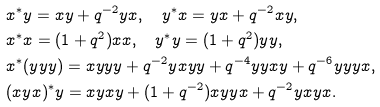<formula> <loc_0><loc_0><loc_500><loc_500>& x ^ { * } y = x y + q ^ { - 2 } y x , \quad y ^ { * } x = y x + q ^ { - 2 } x y , \\ & x ^ { * } x = ( 1 + q ^ { 2 } ) x x , \quad y ^ { * } y = ( 1 + q ^ { 2 } ) y y , \\ & x ^ { * } ( y y y ) = x y y y + q ^ { - 2 } y x y y + q ^ { - 4 } y y x y + q ^ { - 6 } y y y x , \\ & ( x y x ) ^ { * } y = x y x y + ( 1 + q ^ { - 2 } ) x y y x + q ^ { - 2 } y x y x .</formula> 